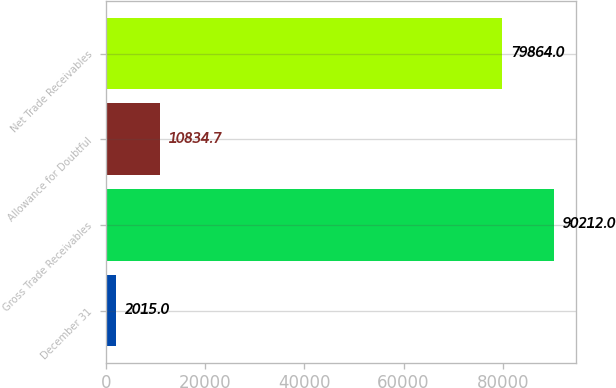Convert chart to OTSL. <chart><loc_0><loc_0><loc_500><loc_500><bar_chart><fcel>December 31<fcel>Gross Trade Receivables<fcel>Allowance for Doubtful<fcel>Net Trade Receivables<nl><fcel>2015<fcel>90212<fcel>10834.7<fcel>79864<nl></chart> 